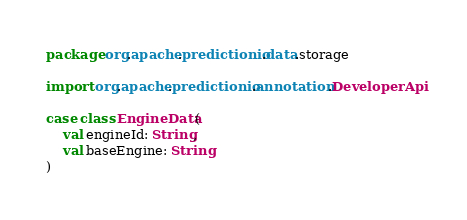Convert code to text. <code><loc_0><loc_0><loc_500><loc_500><_Scala_>package org.apache.predictionio.data.storage

import org.apache.predictionio.annotation.DeveloperApi

case class EngineData(
	val engineId: String,
	val baseEngine: String
)</code> 